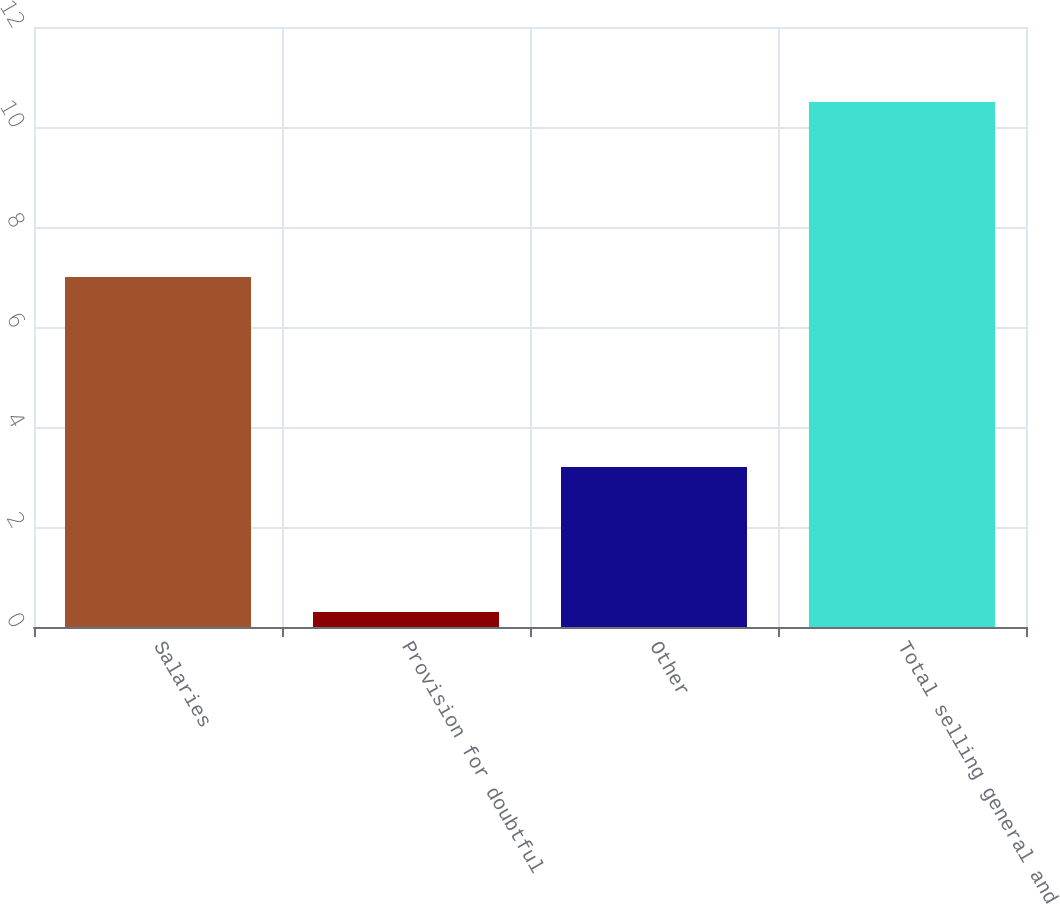Convert chart. <chart><loc_0><loc_0><loc_500><loc_500><bar_chart><fcel>Salaries<fcel>Provision for doubtful<fcel>Other<fcel>Total selling general and<nl><fcel>7<fcel>0.3<fcel>3.2<fcel>10.5<nl></chart> 